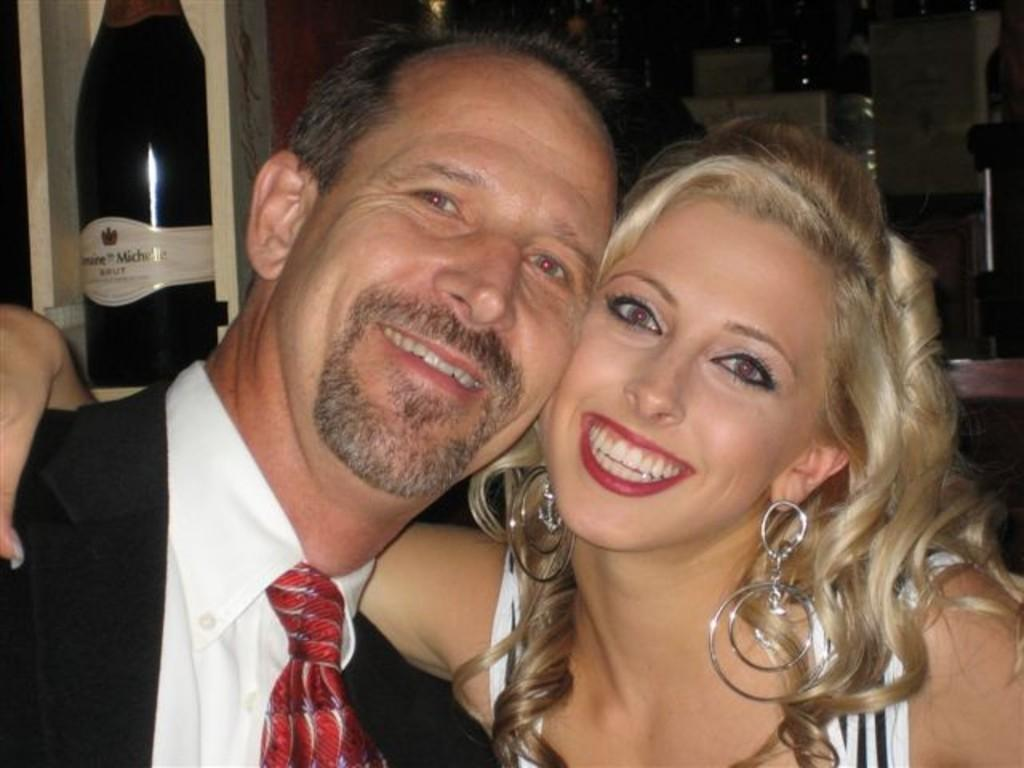Who is present in the image? There is a man and a woman in the image. What expressions do the man and woman have? Both the man and the woman are smiling. What can be seen in the background of the image? There is an alcohol bottle in the background of the image. How is the alcohol bottle positioned in the image? The alcohol bottle is placed in a rack. What type of cable is being used to reward the man and woman in the image? There is no cable or reward present in the image; it only features a man, a woman, and an alcohol bottle in a rack. 